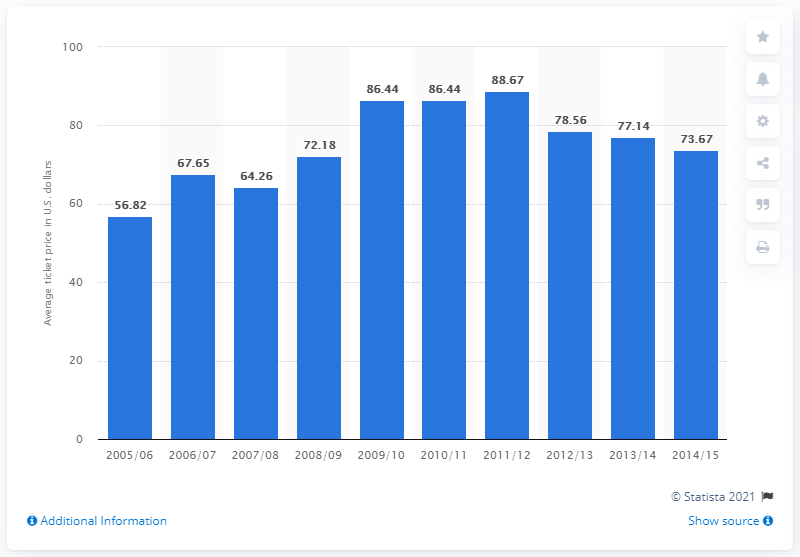Point out several critical features in this image. In the 2005/06 season, the average ticket price was 56.82. 